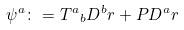<formula> <loc_0><loc_0><loc_500><loc_500>\psi ^ { a } \colon = { T ^ { a } } _ { b } D ^ { b } r + P D ^ { a } r</formula> 